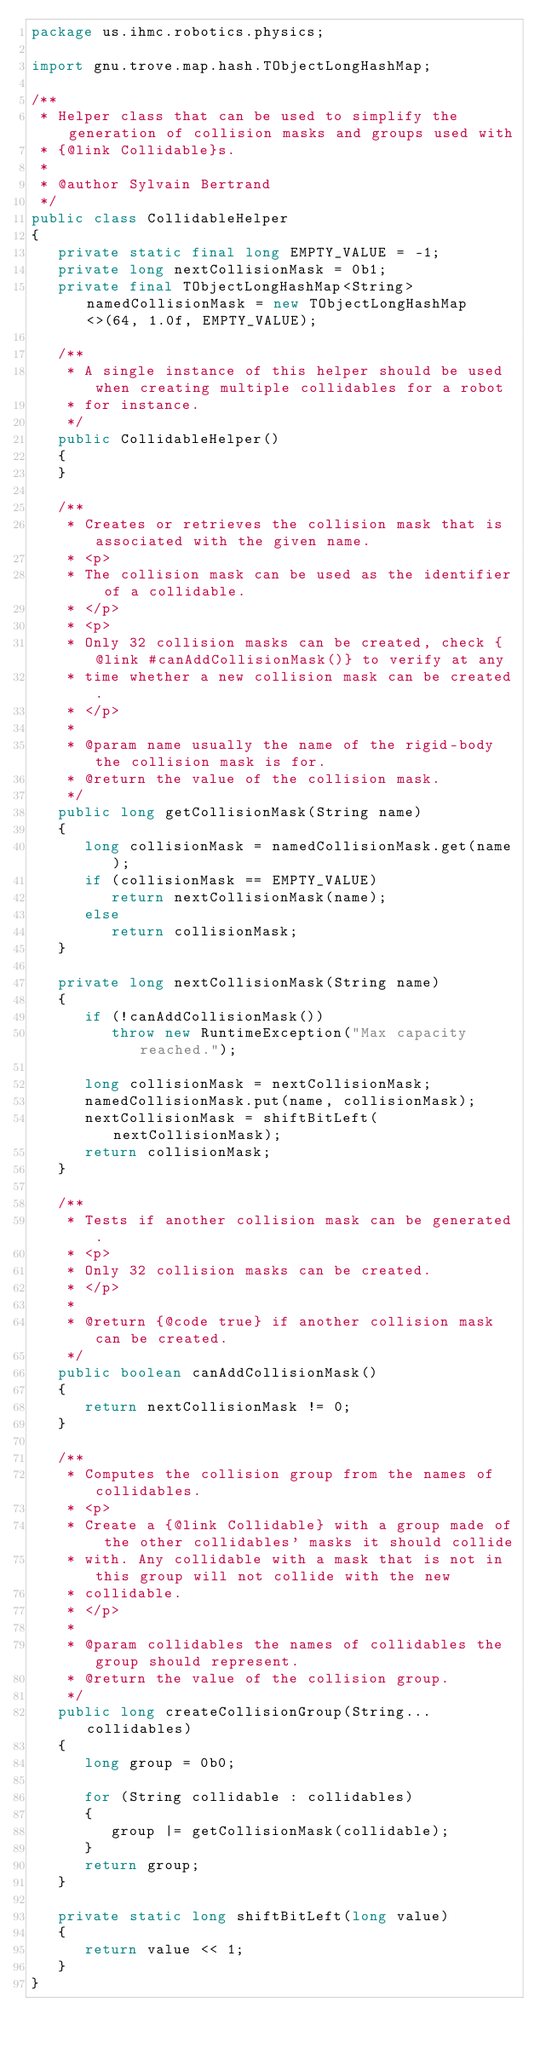<code> <loc_0><loc_0><loc_500><loc_500><_Java_>package us.ihmc.robotics.physics;

import gnu.trove.map.hash.TObjectLongHashMap;

/**
 * Helper class that can be used to simplify the generation of collision masks and groups used with
 * {@link Collidable}s.
 * 
 * @author Sylvain Bertrand
 */
public class CollidableHelper
{
   private static final long EMPTY_VALUE = -1;
   private long nextCollisionMask = 0b1;
   private final TObjectLongHashMap<String> namedCollisionMask = new TObjectLongHashMap<>(64, 1.0f, EMPTY_VALUE);

   /**
    * A single instance of this helper should be used when creating multiple collidables for a robot
    * for instance.
    */
   public CollidableHelper()
   {
   }

   /**
    * Creates or retrieves the collision mask that is associated with the given name.
    * <p>
    * The collision mask can be used as the identifier of a collidable.
    * </p>
    * <p>
    * Only 32 collision masks can be created, check {@link #canAddCollisionMask()} to verify at any
    * time whether a new collision mask can be created.
    * </p>
    * 
    * @param name usually the name of the rigid-body the collision mask is for.
    * @return the value of the collision mask.
    */
   public long getCollisionMask(String name)
   {
      long collisionMask = namedCollisionMask.get(name);
      if (collisionMask == EMPTY_VALUE)
         return nextCollisionMask(name);
      else
         return collisionMask;
   }

   private long nextCollisionMask(String name)
   {
      if (!canAddCollisionMask())
         throw new RuntimeException("Max capacity reached.");

      long collisionMask = nextCollisionMask;
      namedCollisionMask.put(name, collisionMask);
      nextCollisionMask = shiftBitLeft(nextCollisionMask);
      return collisionMask;
   }

   /**
    * Tests if another collision mask can be generated.
    * <p>
    * Only 32 collision masks can be created.
    * </p>
    * 
    * @return {@code true} if another collision mask can be created.
    */
   public boolean canAddCollisionMask()
   {
      return nextCollisionMask != 0;
   }

   /**
    * Computes the collision group from the names of collidables.
    * <p>
    * Create a {@link Collidable} with a group made of the other collidables' masks it should collide
    * with. Any collidable with a mask that is not in this group will not collide with the new
    * collidable.
    * </p>
    * 
    * @param collidables the names of collidables the group should represent.
    * @return the value of the collision group.
    */
   public long createCollisionGroup(String... collidables)
   {
      long group = 0b0;

      for (String collidable : collidables)
      {
         group |= getCollisionMask(collidable);
      }
      return group;
   }

   private static long shiftBitLeft(long value)
   {
      return value << 1;
   }
}
</code> 